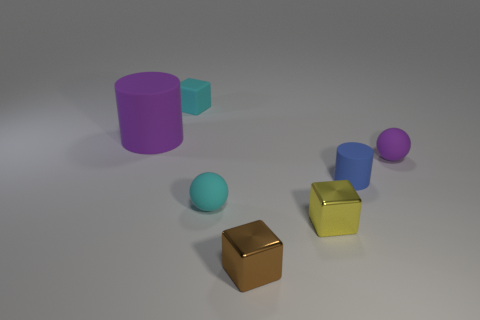If this image had a sound, what would it be? The image conveys a sense of stillness and quiet. If it produced a sound, it might be a soft hum resembling the quiet ambiance of a room with no significant noise, just the subtle sounds of the environment. 